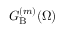<formula> <loc_0><loc_0><loc_500><loc_500>G _ { B } ^ { ( m ) } ( \Omega )</formula> 